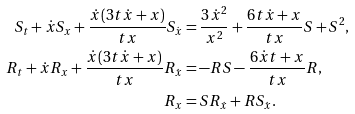Convert formula to latex. <formula><loc_0><loc_0><loc_500><loc_500>S _ { t } + \dot { x } S _ { x } + \frac { \dot { x } ( 3 t \dot { x } + x ) } { t x } S _ { \dot { x } } & = \frac { 3 \dot { x } ^ { 2 } } { x ^ { 2 } } + \frac { 6 t \dot { x } + x } { t x } S + S ^ { 2 } , \\ R _ { t } + \dot { x } R _ { x } + \frac { \dot { x } ( 3 t \dot { x } + x ) } { t x } R _ { \dot { x } } & = - R S - \frac { 6 \dot { x } t + x } { t x } R , \\ R _ { x } & = S R _ { \dot { x } } + R S _ { \dot { x } } .</formula> 